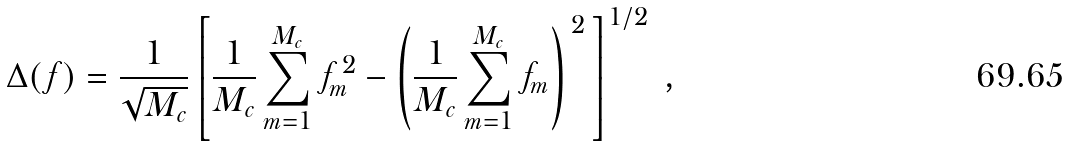<formula> <loc_0><loc_0><loc_500><loc_500>\Delta ( f ) = \frac { 1 } { \sqrt { M _ { c } } } \left [ \frac { 1 } { M _ { c } } \sum _ { m = 1 } ^ { M _ { c } } f ^ { \, 2 } _ { m } - \left ( \frac { 1 } { M _ { c } } \sum _ { m = 1 } ^ { M _ { c } } f _ { m } \right ) ^ { \, 2 } \, \right ] ^ { 1 / 2 } \ ,</formula> 